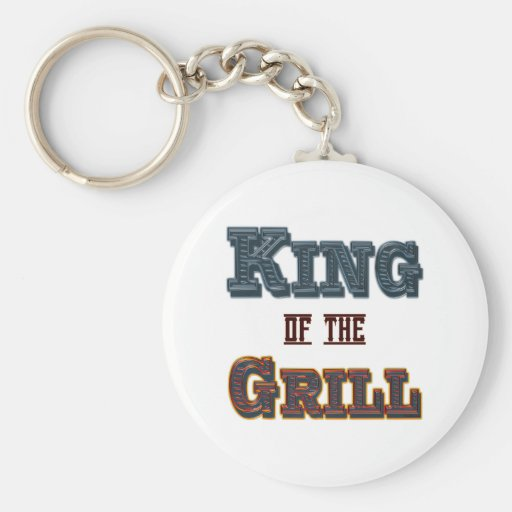What type of material is the keychain made from, and how does this material choice enhance its design? The keychain appears to be made from a durable synthetic material, possibly a high-grade plastic or a resin, which ensures that the keychain is both lightweight and capable of retaining the vibrant colors of its design. This material choice is practical for an item that might frequently be exposed to outdoor elements during grilling events. Additionally, the glossy finish enhances the vivid colors and makes the keychain more visually appealing. 